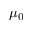<formula> <loc_0><loc_0><loc_500><loc_500>\mu _ { 0 }</formula> 